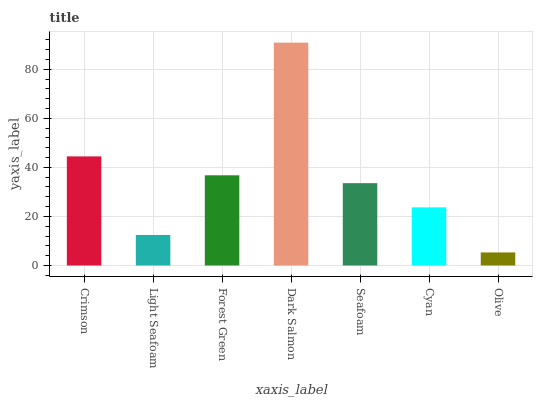Is Olive the minimum?
Answer yes or no. Yes. Is Dark Salmon the maximum?
Answer yes or no. Yes. Is Light Seafoam the minimum?
Answer yes or no. No. Is Light Seafoam the maximum?
Answer yes or no. No. Is Crimson greater than Light Seafoam?
Answer yes or no. Yes. Is Light Seafoam less than Crimson?
Answer yes or no. Yes. Is Light Seafoam greater than Crimson?
Answer yes or no. No. Is Crimson less than Light Seafoam?
Answer yes or no. No. Is Seafoam the high median?
Answer yes or no. Yes. Is Seafoam the low median?
Answer yes or no. Yes. Is Cyan the high median?
Answer yes or no. No. Is Dark Salmon the low median?
Answer yes or no. No. 